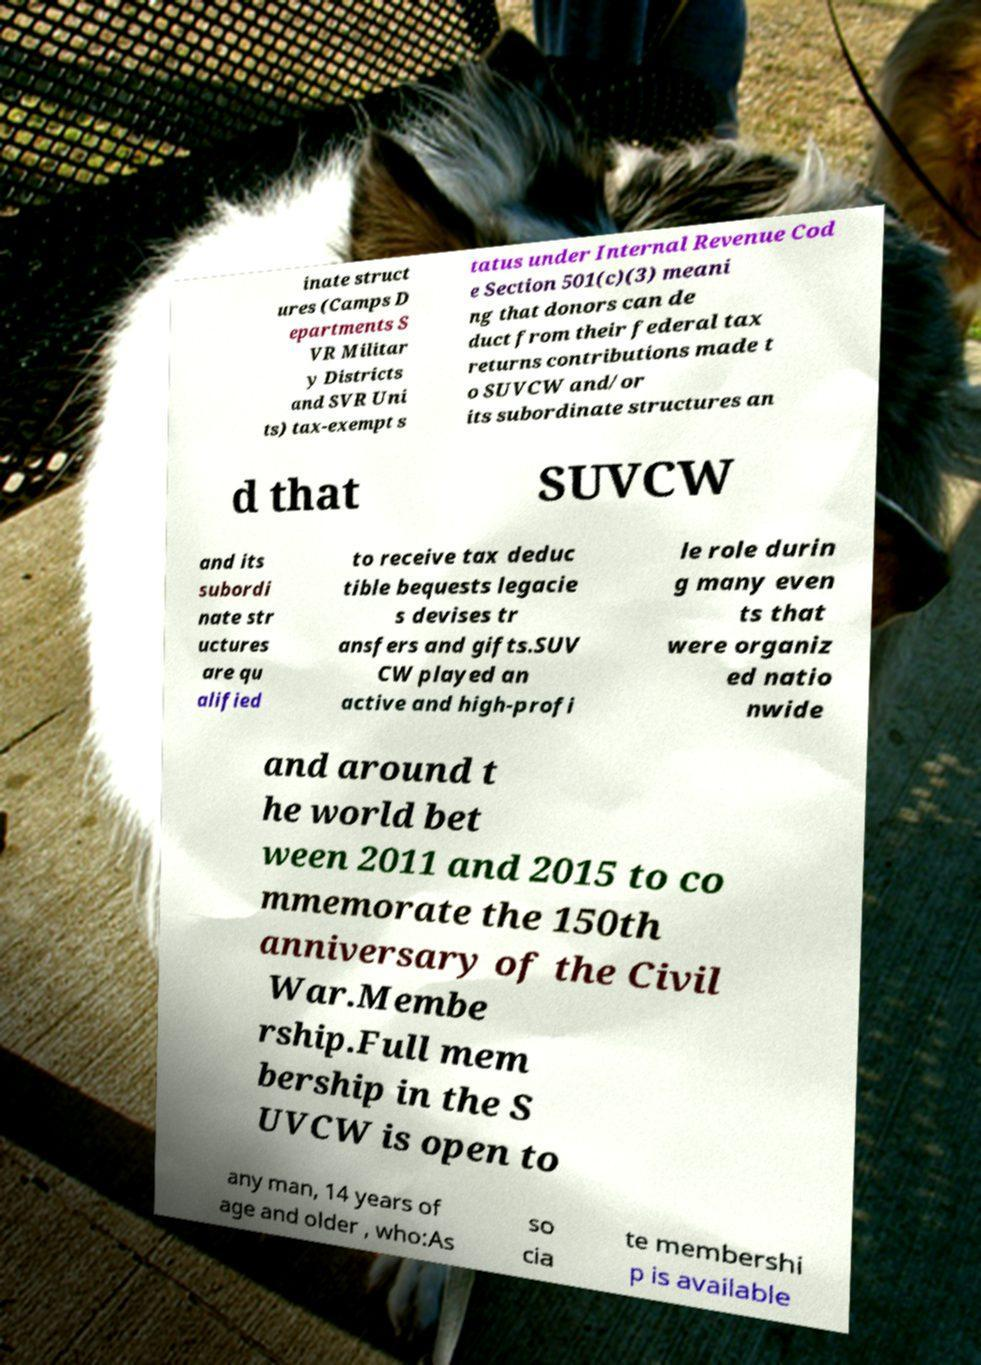Can you read and provide the text displayed in the image?This photo seems to have some interesting text. Can you extract and type it out for me? inate struct ures (Camps D epartments S VR Militar y Districts and SVR Uni ts) tax-exempt s tatus under Internal Revenue Cod e Section 501(c)(3) meani ng that donors can de duct from their federal tax returns contributions made t o SUVCW and/or its subordinate structures an d that SUVCW and its subordi nate str uctures are qu alified to receive tax deduc tible bequests legacie s devises tr ansfers and gifts.SUV CW played an active and high-profi le role durin g many even ts that were organiz ed natio nwide and around t he world bet ween 2011 and 2015 to co mmemorate the 150th anniversary of the Civil War.Membe rship.Full mem bership in the S UVCW is open to any man, 14 years of age and older , who:As so cia te membershi p is available 